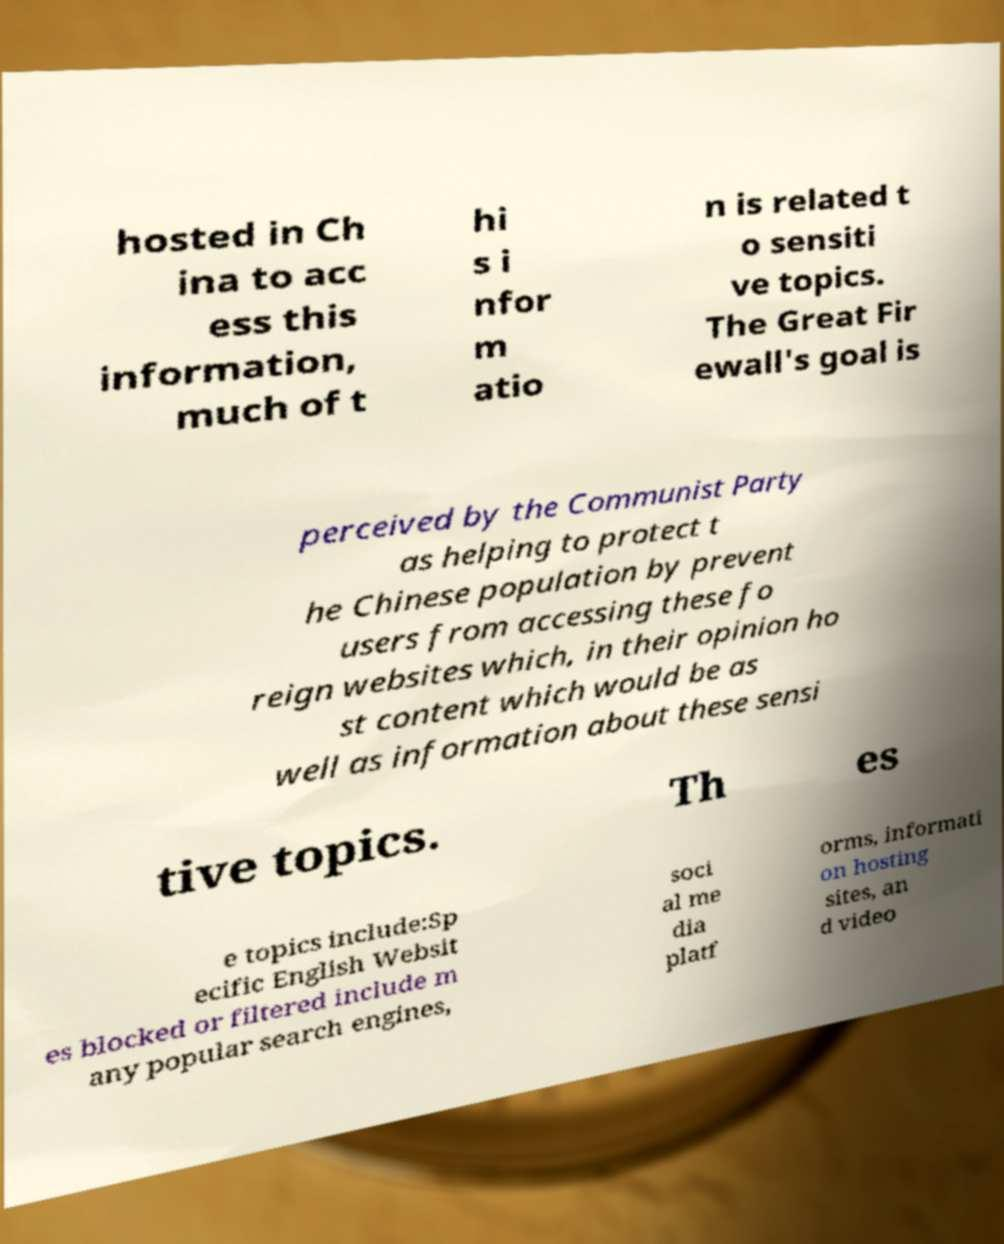For documentation purposes, I need the text within this image transcribed. Could you provide that? hosted in Ch ina to acc ess this information, much of t hi s i nfor m atio n is related t o sensiti ve topics. The Great Fir ewall's goal is perceived by the Communist Party as helping to protect t he Chinese population by prevent users from accessing these fo reign websites which, in their opinion ho st content which would be as well as information about these sensi tive topics. Th es e topics include:Sp ecific English Websit es blocked or filtered include m any popular search engines, soci al me dia platf orms, informati on hosting sites, an d video 